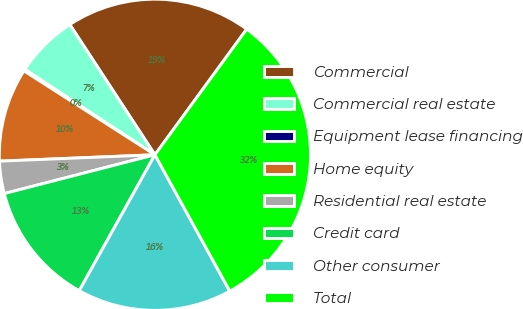Convert chart. <chart><loc_0><loc_0><loc_500><loc_500><pie_chart><fcel>Commercial<fcel>Commercial real estate<fcel>Equipment lease financing<fcel>Home equity<fcel>Residential real estate<fcel>Credit card<fcel>Other consumer<fcel>Total<nl><fcel>19.26%<fcel>6.54%<fcel>0.18%<fcel>9.72%<fcel>3.36%<fcel>12.9%<fcel>16.08%<fcel>31.97%<nl></chart> 